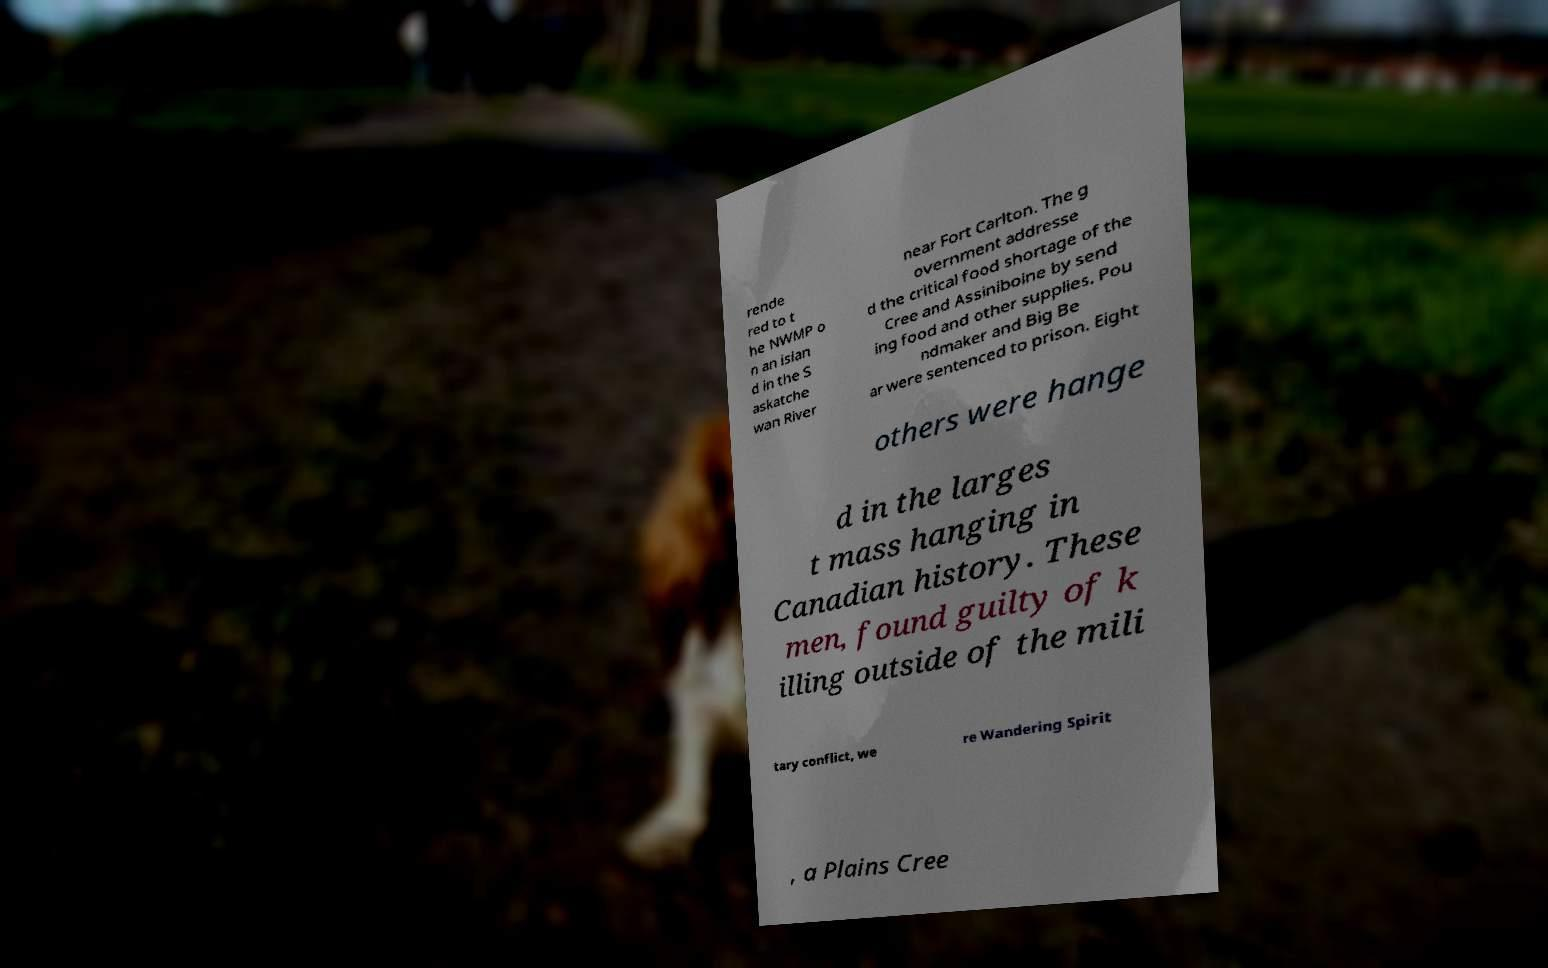Could you assist in decoding the text presented in this image and type it out clearly? rende red to t he NWMP o n an islan d in the S askatche wan River near Fort Carlton. The g overnment addresse d the critical food shortage of the Cree and Assiniboine by send ing food and other supplies. Pou ndmaker and Big Be ar were sentenced to prison. Eight others were hange d in the larges t mass hanging in Canadian history. These men, found guilty of k illing outside of the mili tary conflict, we re Wandering Spirit , a Plains Cree 